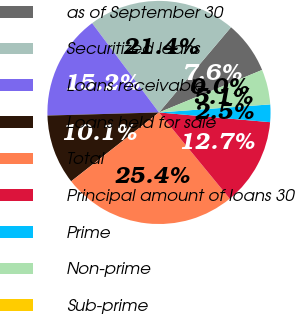Convert chart. <chart><loc_0><loc_0><loc_500><loc_500><pie_chart><fcel>as of September 30<fcel>Securitized loans<fcel>Loans receivable<fcel>Loans held for sale<fcel>Total<fcel>Principal amount of loans 30<fcel>Prime<fcel>Non-prime<fcel>Sub-prime<nl><fcel>7.61%<fcel>21.4%<fcel>15.21%<fcel>10.14%<fcel>25.35%<fcel>12.68%<fcel>2.54%<fcel>5.07%<fcel>0.0%<nl></chart> 